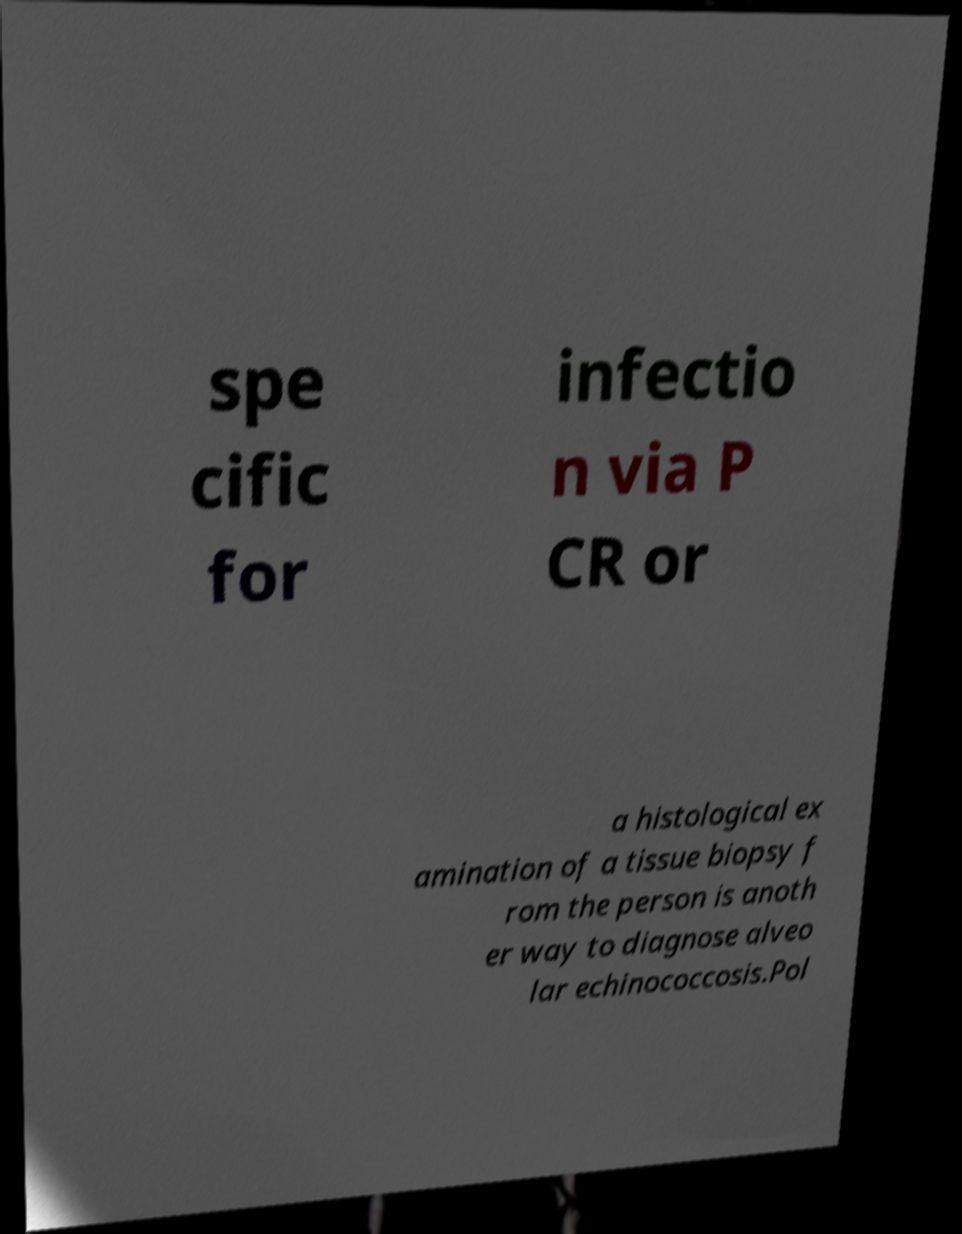What messages or text are displayed in this image? I need them in a readable, typed format. spe cific for infectio n via P CR or a histological ex amination of a tissue biopsy f rom the person is anoth er way to diagnose alveo lar echinococcosis.Pol 